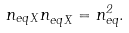Convert formula to latex. <formula><loc_0><loc_0><loc_500><loc_500>n _ { e q \, X } n _ { e q \, \bar { X } } = n _ { e q } ^ { 2 } .</formula> 